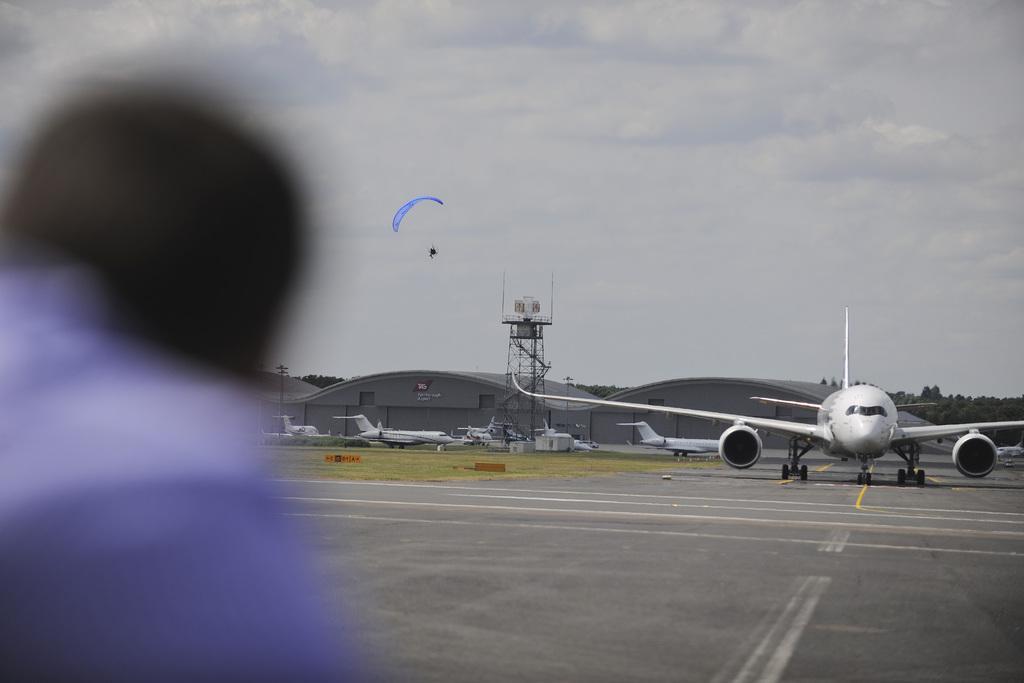Describe this image in one or two sentences. In this image we can see flight on a runway. In the back there is a tower. Also there are flights and a building. On the left side we can see person and looking blur. In the background there is sky with clouds. And there is a parachute. Also there are trees. 